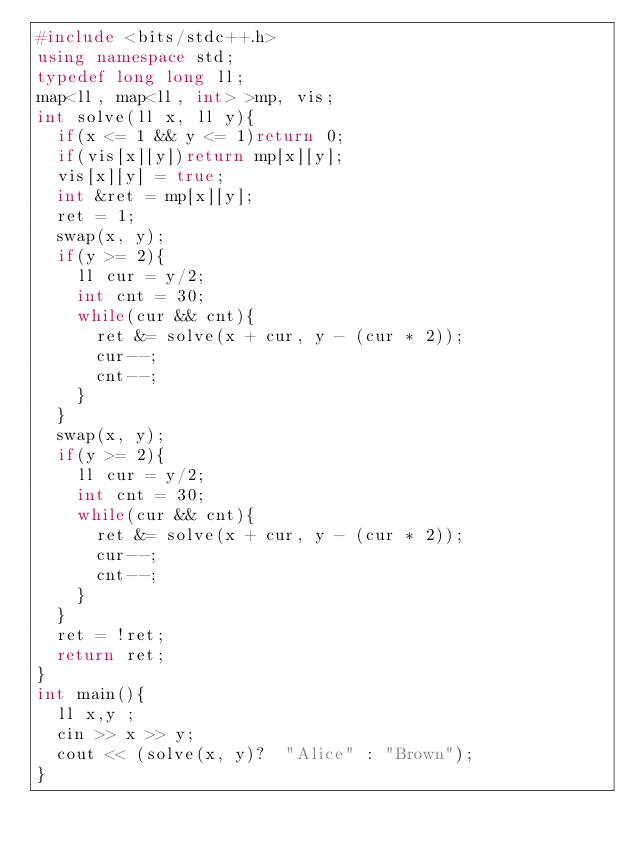Convert code to text. <code><loc_0><loc_0><loc_500><loc_500><_C++_>#include <bits/stdc++.h>
using namespace std;
typedef long long ll;
map<ll, map<ll, int> >mp, vis;
int solve(ll x, ll y){
  if(x <= 1 && y <= 1)return 0;
  if(vis[x][y])return mp[x][y];
  vis[x][y] = true;
  int &ret = mp[x][y];
  ret = 1;
  swap(x, y);
  if(y >= 2){
    ll cur = y/2;
    int cnt = 30;
    while(cur && cnt){
      ret &= solve(x + cur, y - (cur * 2));
      cur--;
      cnt--;
    }
  }
  swap(x, y);
  if(y >= 2){
    ll cur = y/2;
    int cnt = 30;
    while(cur && cnt){
      ret &= solve(x + cur, y - (cur * 2));
      cur--;
      cnt--;
    }
  }
  ret = !ret;
  return ret;
}
int main(){
  ll x,y ;
  cin >> x >> y;
  cout << (solve(x, y)?  "Alice" : "Brown");
}
</code> 